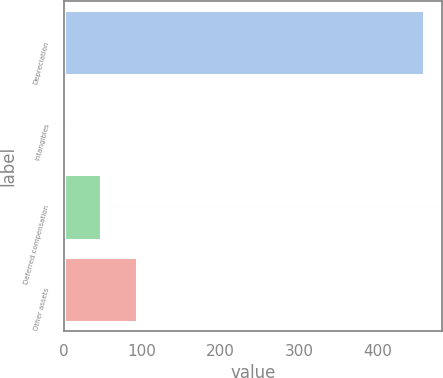<chart> <loc_0><loc_0><loc_500><loc_500><bar_chart><fcel>Depreciation<fcel>Intangibles<fcel>Deferred compensation<fcel>Other assets<nl><fcel>459<fcel>2<fcel>47.7<fcel>93.4<nl></chart> 